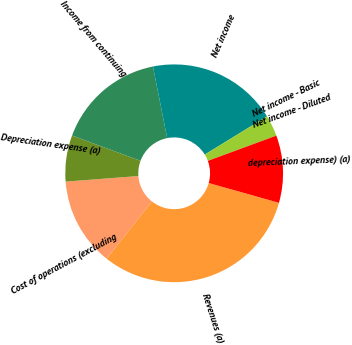Convert chart. <chart><loc_0><loc_0><loc_500><loc_500><pie_chart><fcel>Revenues (a)<fcel>Cost of operations (excluding<fcel>Depreciation expense (a)<fcel>Income from continuing<fcel>Net income<fcel>Net income - Basic<fcel>Net income - Diluted<fcel>depreciation expense) (a)<nl><fcel>31.29%<fcel>13.12%<fcel>6.86%<fcel>16.24%<fcel>19.37%<fcel>3.13%<fcel>0.0%<fcel>9.99%<nl></chart> 